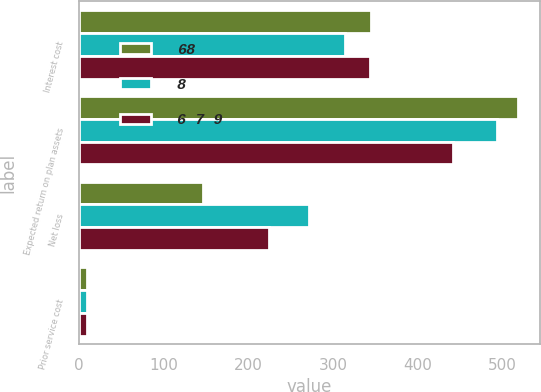Convert chart. <chart><loc_0><loc_0><loc_500><loc_500><stacked_bar_chart><ecel><fcel>Interest cost<fcel>Expected return on plan assets<fcel>Net loss<fcel>Prior service cost<nl><fcel>68<fcel>345<fcel>518<fcel>147<fcel>10<nl><fcel>8<fcel>314<fcel>493<fcel>271<fcel>10<nl><fcel>6 7 9<fcel>344<fcel>442<fcel>224<fcel>10<nl></chart> 